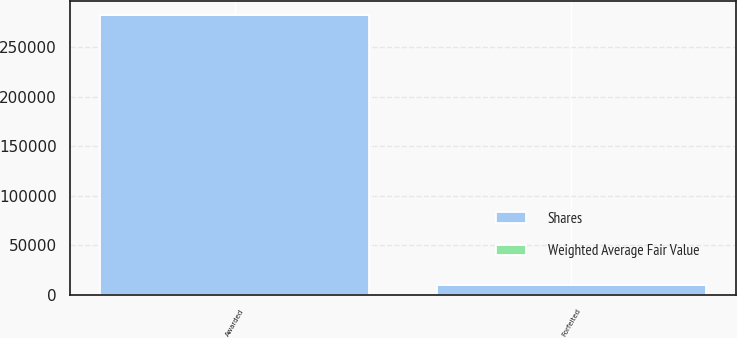<chart> <loc_0><loc_0><loc_500><loc_500><stacked_bar_chart><ecel><fcel>Awarded<fcel>Forfeited<nl><fcel>Shares<fcel>282423<fcel>10000<nl><fcel>Weighted Average Fair Value<fcel>67.11<fcel>43.41<nl></chart> 